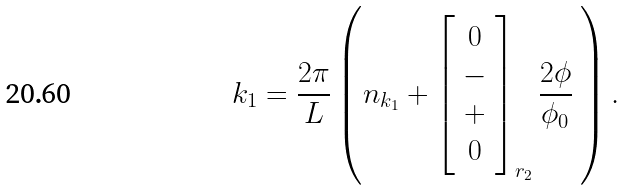<formula> <loc_0><loc_0><loc_500><loc_500>k _ { 1 } = \frac { 2 \pi } { L } \left ( n _ { k _ { 1 } } + \left [ \begin{array} { c } 0 \\ - \\ + \\ 0 \end{array} \right ] _ { r _ { 2 } } \frac { 2 \phi } { \phi _ { 0 } } \ \right ) .</formula> 